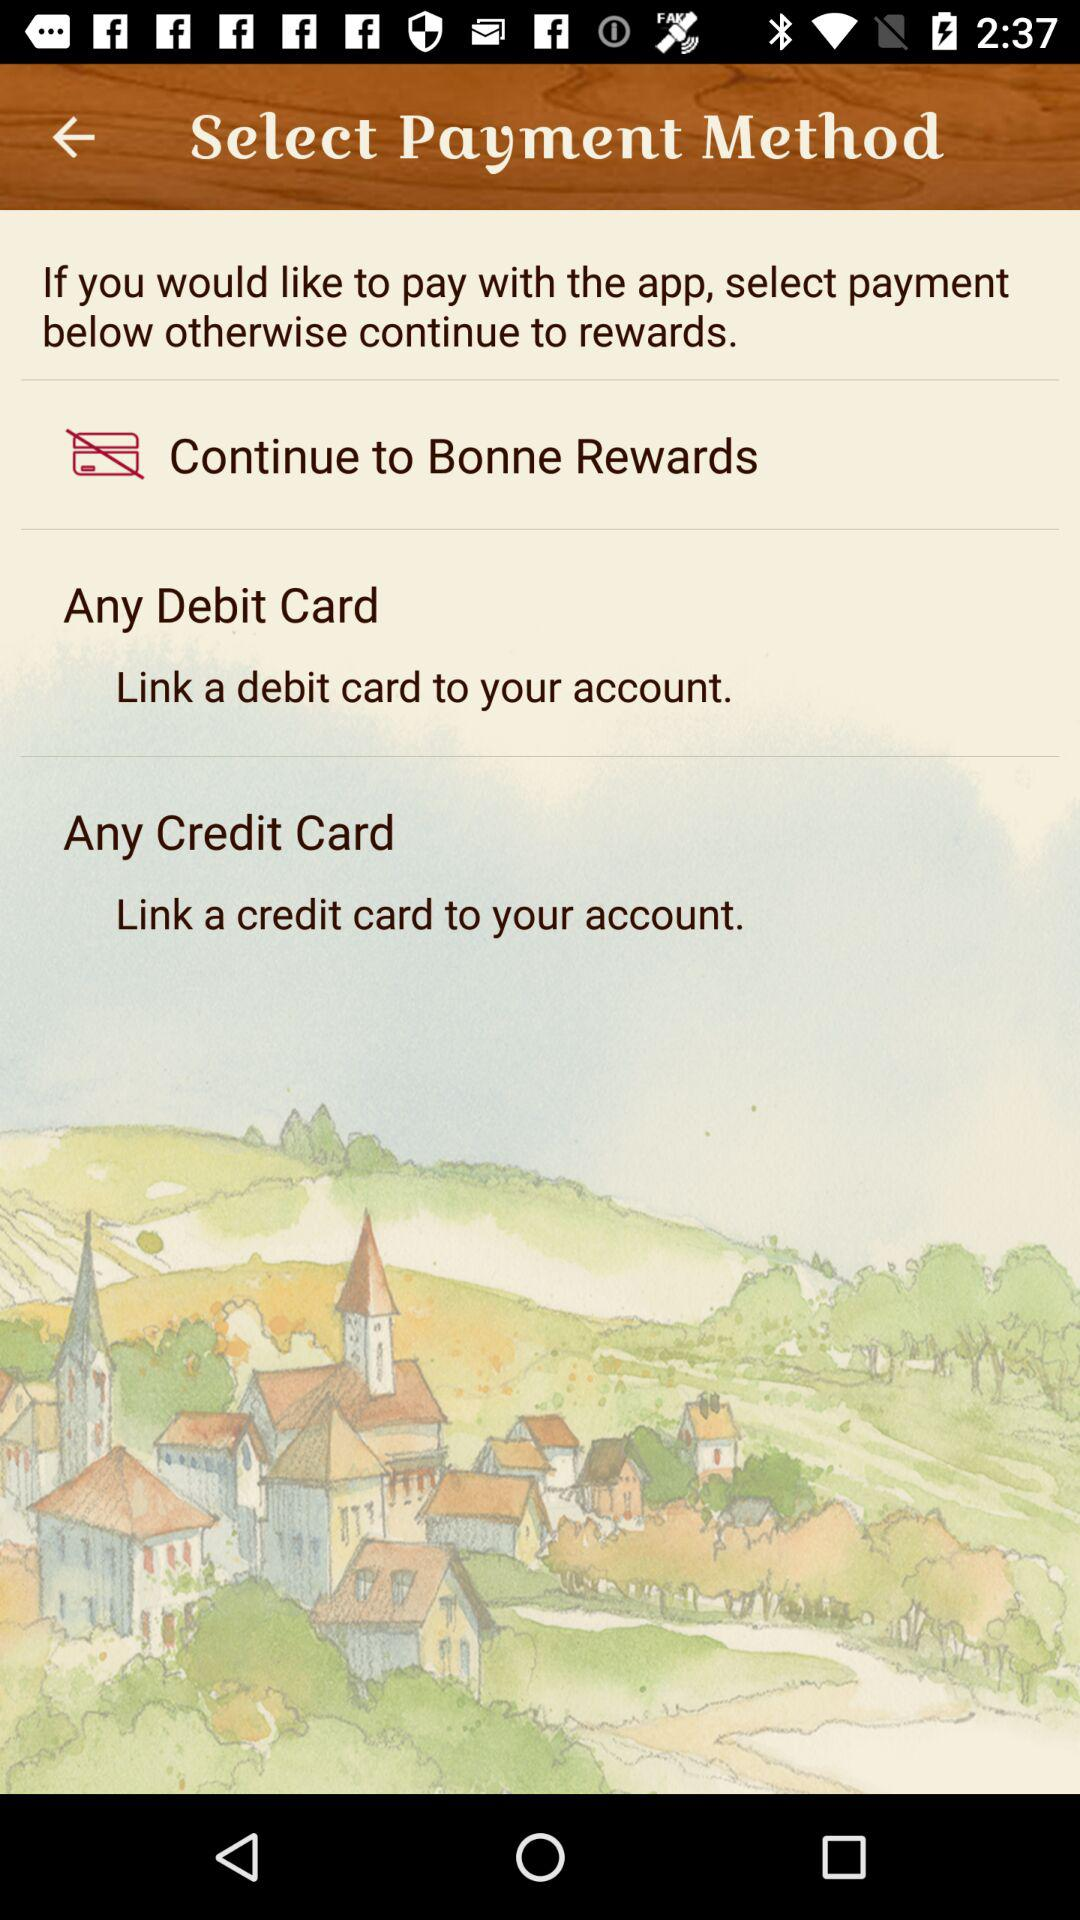What are the payment options if I want to pay through the application? If you want to pay through the application, the payment options are "Any Debit Card" and "Any Credit Card". 